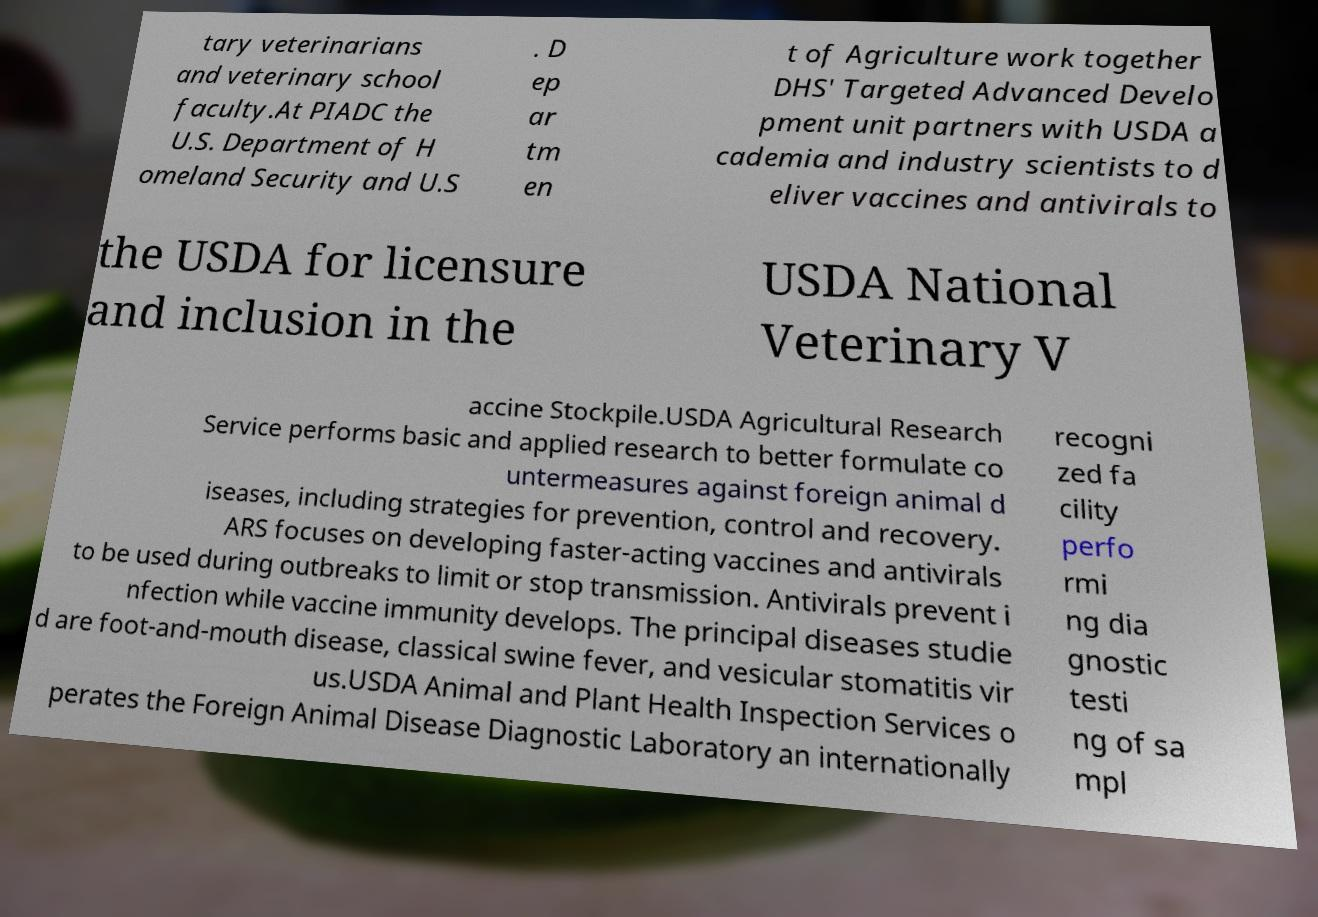Can you accurately transcribe the text from the provided image for me? tary veterinarians and veterinary school faculty.At PIADC the U.S. Department of H omeland Security and U.S . D ep ar tm en t of Agriculture work together DHS' Targeted Advanced Develo pment unit partners with USDA a cademia and industry scientists to d eliver vaccines and antivirals to the USDA for licensure and inclusion in the USDA National Veterinary V accine Stockpile.USDA Agricultural Research Service performs basic and applied research to better formulate co untermeasures against foreign animal d iseases, including strategies for prevention, control and recovery. ARS focuses on developing faster-acting vaccines and antivirals to be used during outbreaks to limit or stop transmission. Antivirals prevent i nfection while vaccine immunity develops. The principal diseases studie d are foot-and-mouth disease, classical swine fever, and vesicular stomatitis vir us.USDA Animal and Plant Health Inspection Services o perates the Foreign Animal Disease Diagnostic Laboratory an internationally recogni zed fa cility perfo rmi ng dia gnostic testi ng of sa mpl 